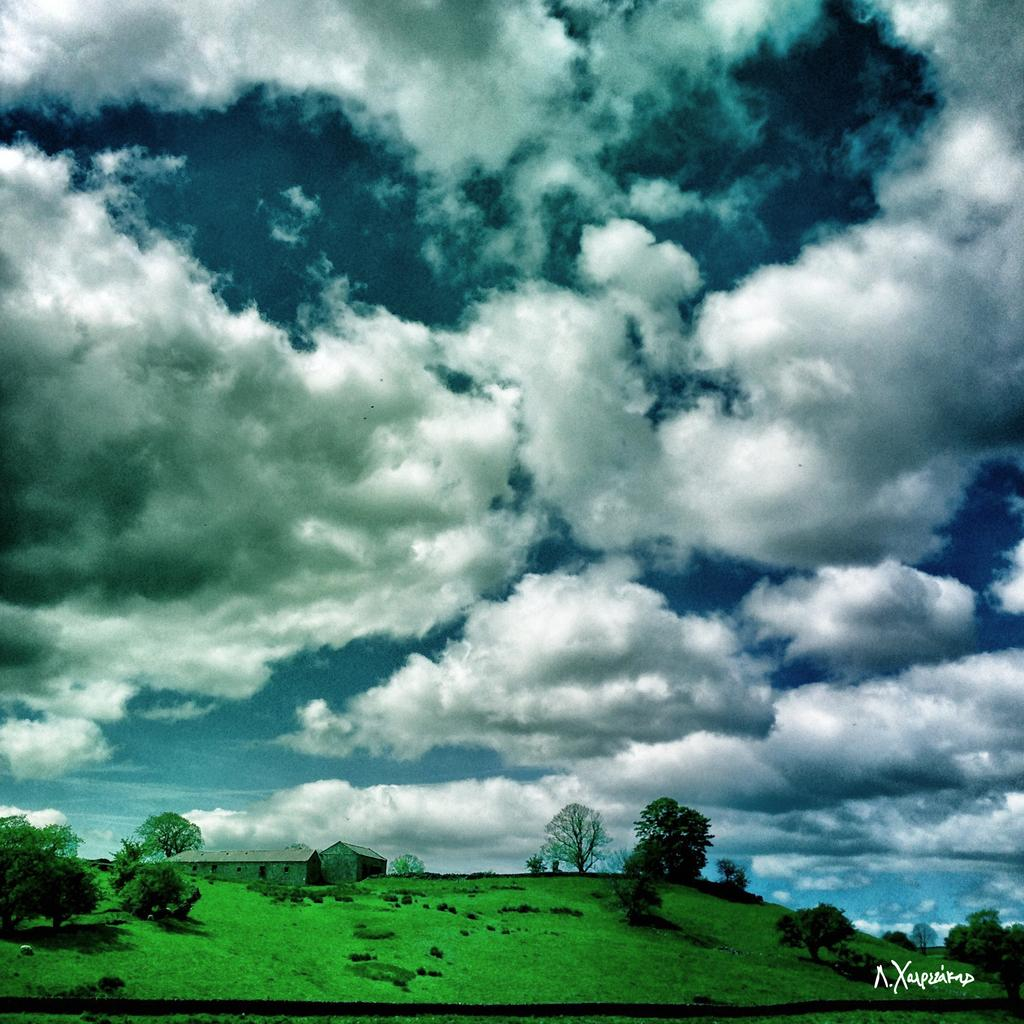What is the main structure in the center of the image? There is a building in the center of the image. What other architectural elements can be seen in the image? There is a wall and a roof visible in the image. What type of vegetation is present in the image? There are trees, plants, and grass visible in the image. What is visible in the background of the image? There is a sky visible in the background of the image, with clouds present. Can you describe the watermark in the image? There is a watermark on the right bottom of the image. How does the heat affect the boundary of the building in the image? There is no mention of heat or a boundary in the image, so it cannot be determined how heat might affect the building. 